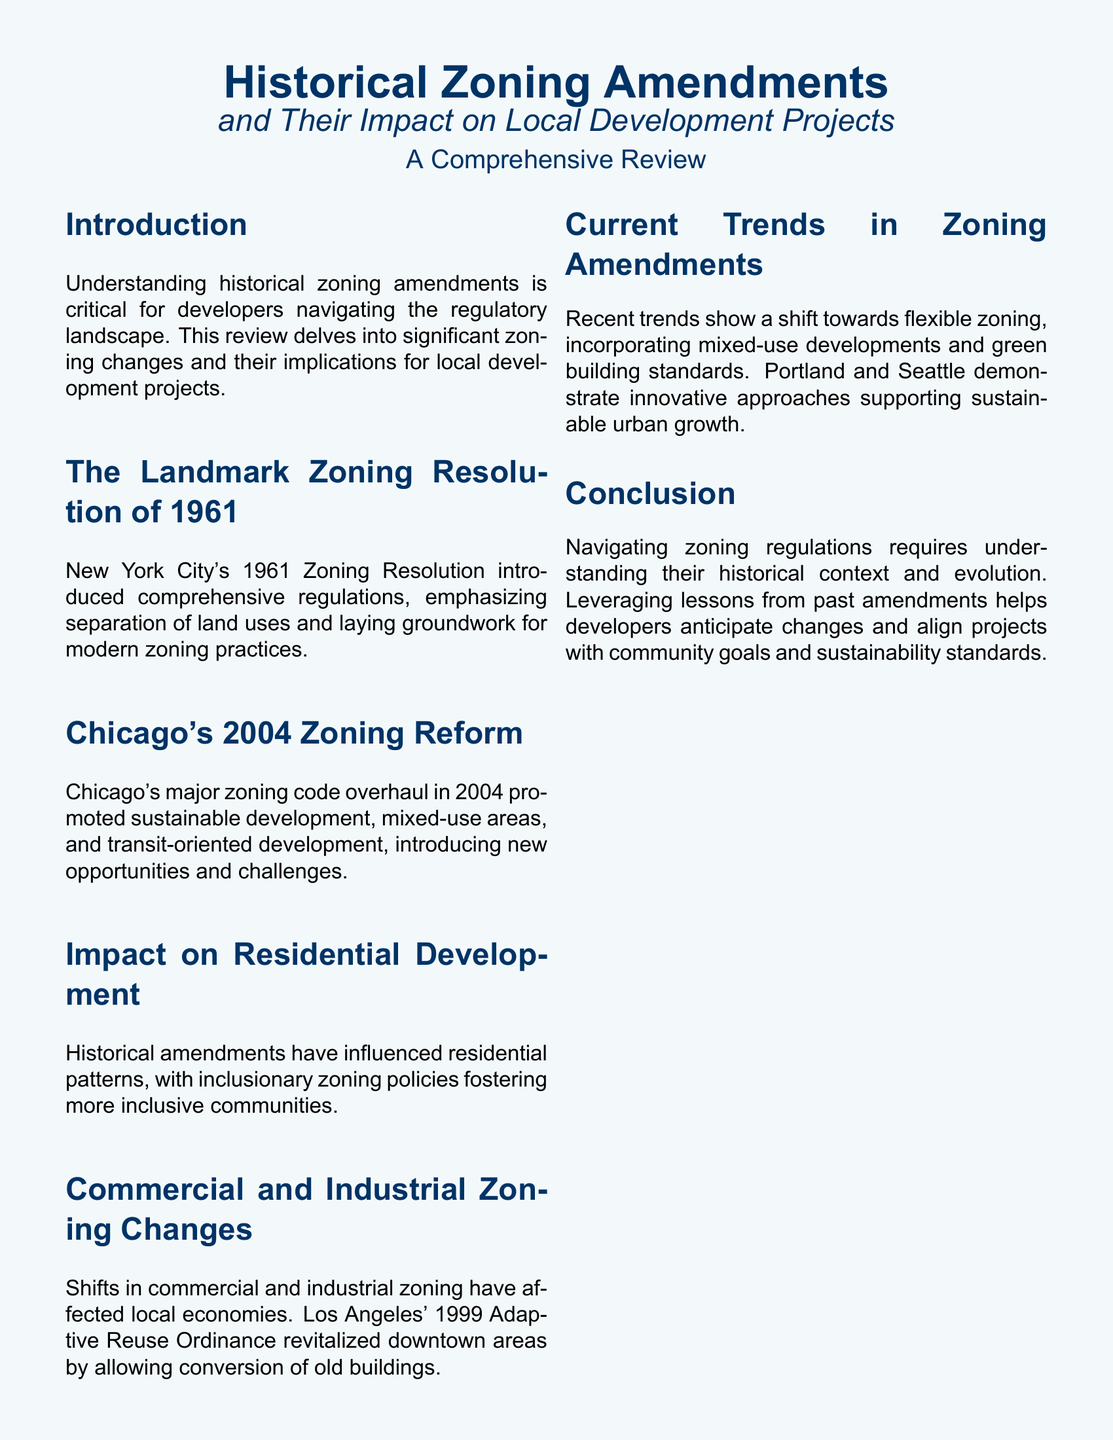What is the title of the document? The title is given at the top of the document and provides the main subject matter being reviewed.
Answer: Historical Zoning Amendments and Their Impact on Local Development Projects Which zoning resolution is discussed in the document? The document specifically mentions New York City's zoning resolution from 1961 as a landmark regulation.
Answer: 1961 Zoning Resolution What year was Chicago's zoning reform enacted? The document details the major zoning code overhaul in Chicago that occurred in 2004.
Answer: 2004 What is one effect of inclusionary zoning policies? The document states that these policies have fostered more inclusive communities in residential areas.
Answer: Inclusive communities Which ordinance revitalized downtown areas in Los Angeles? The document mentions the Adaptive Reuse Ordinance as a significant factor in revitalizing certain areas.
Answer: Adaptive Reuse Ordinance What trend is noted in recent zoning amendments? The document indicates a shift towards flexible zoning as a prominent trend in recent years.
Answer: Flexible zoning What emphasizes the importance of understanding historical zoning amendments? The conclusion section highlights the necessity of understanding this historical context for effective navigation of regulations.
Answer: Navigating zoning regulations What is the primary appeal made to developers in the document? The closing section includes an invitation for collaboration to align projects with community goals and sustainability standards.
Answer: Collaborate to align projects 